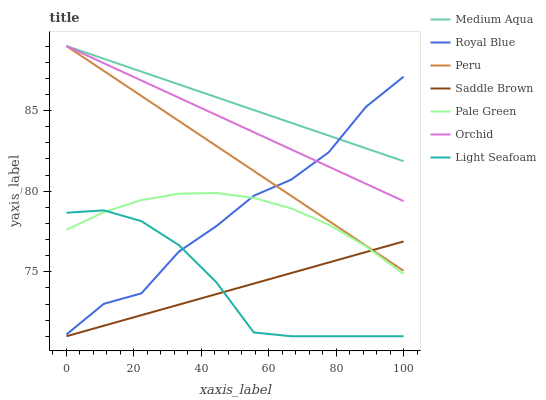Does Pale Green have the minimum area under the curve?
Answer yes or no. No. Does Pale Green have the maximum area under the curve?
Answer yes or no. No. Is Pale Green the smoothest?
Answer yes or no. No. Is Pale Green the roughest?
Answer yes or no. No. Does Pale Green have the lowest value?
Answer yes or no. No. Does Pale Green have the highest value?
Answer yes or no. No. Is Saddle Brown less than Royal Blue?
Answer yes or no. Yes. Is Orchid greater than Saddle Brown?
Answer yes or no. Yes. Does Saddle Brown intersect Royal Blue?
Answer yes or no. No. 